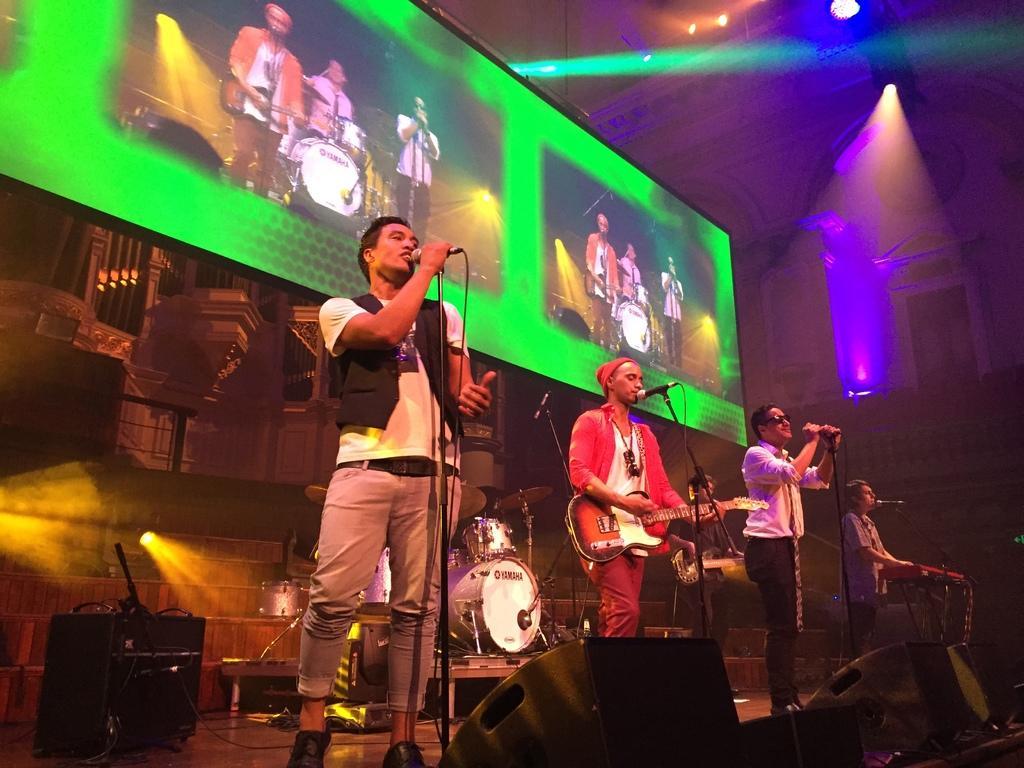Can you describe this image briefly? In this picture we can see four persons on stage playing musical instruments such as guitar, piano and singing on mic and in background we can see speakers, wall, screen, lights, window. 